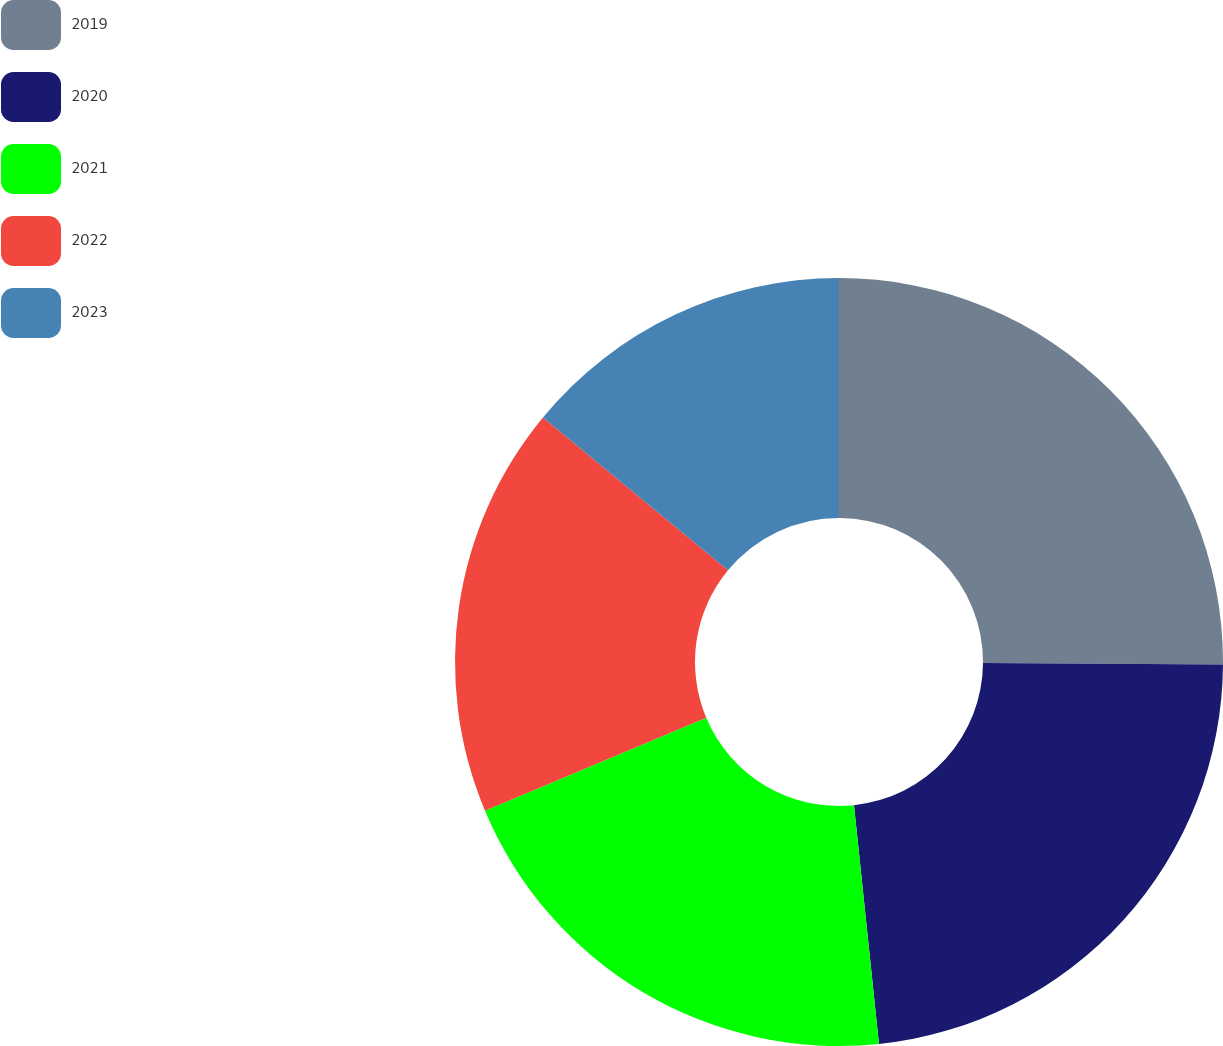Convert chart to OTSL. <chart><loc_0><loc_0><loc_500><loc_500><pie_chart><fcel>2019<fcel>2020<fcel>2021<fcel>2022<fcel>2023<nl><fcel>25.1%<fcel>23.24%<fcel>20.33%<fcel>17.32%<fcel>14.01%<nl></chart> 